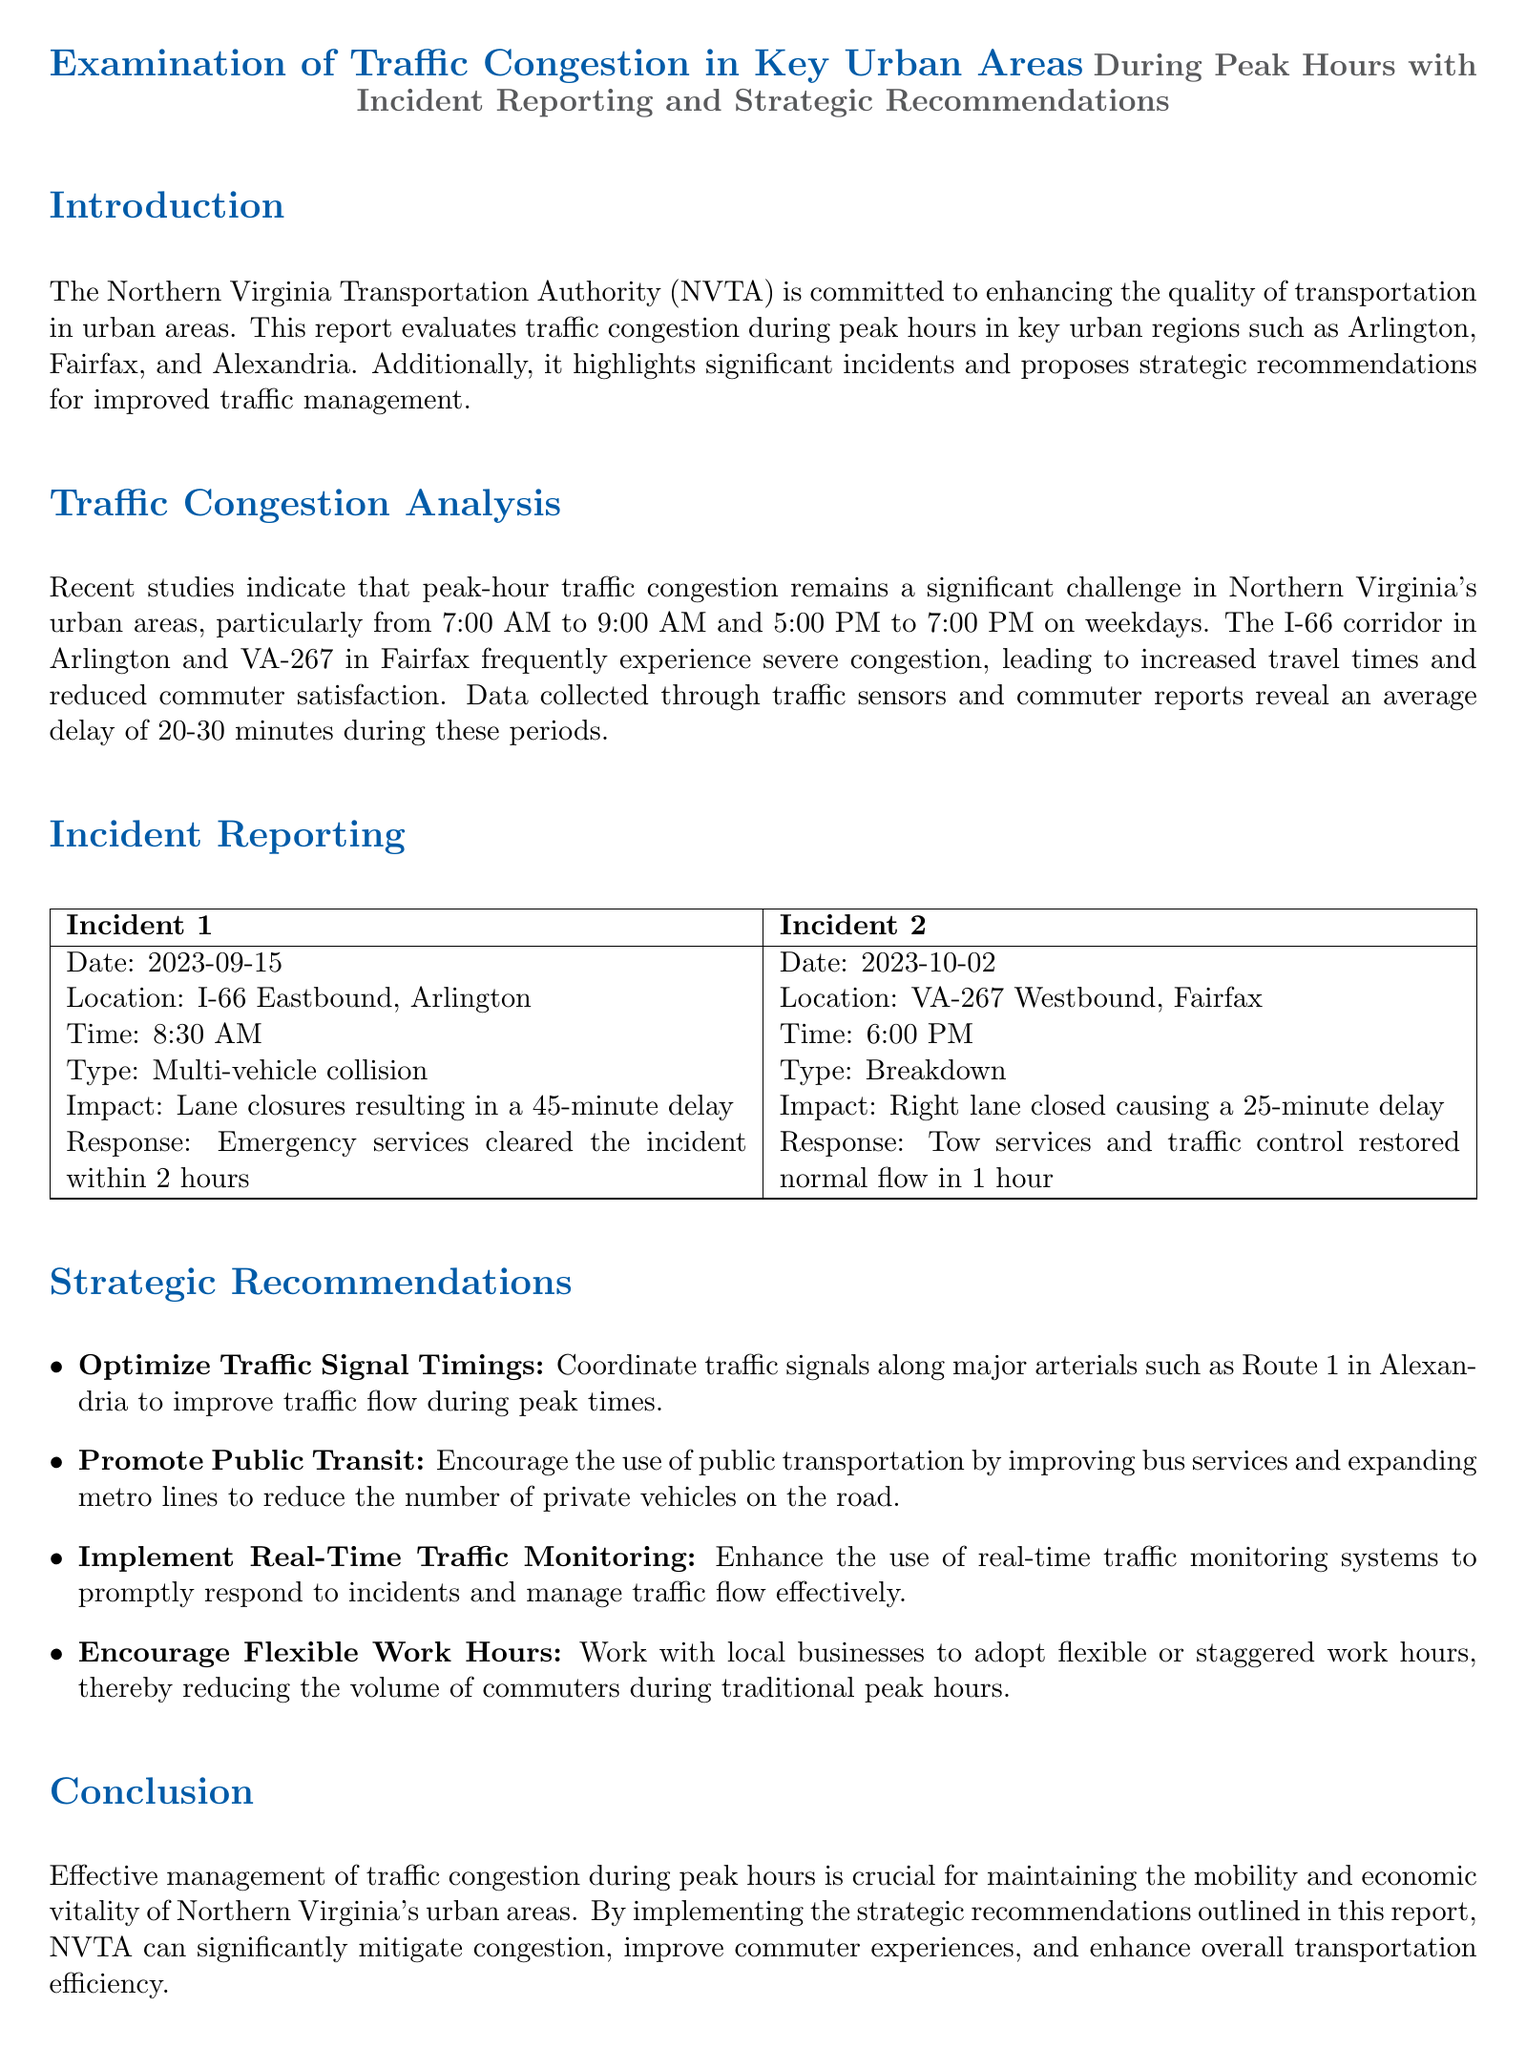What are the peak hours for traffic congestion? The peak hours for traffic congestion are specifically mentioned in the report as being from 7:00 AM to 9:00 AM and 5:00 PM to 7:00 PM on weekdays.
Answer: 7:00 AM to 9:00 AM and 5:00 PM to 7:00 PM Which corridor frequently experiences severe congestion in Arlington? The report identifies the I-66 corridor in Arlington as frequently experiencing severe congestion during peak hours.
Answer: I-66 What was the impact of Incident 1 on traffic? The incident report states that Incident 1 resulted in lane closures causing a 45-minute delay for commuters.
Answer: 45-minute delay How long did it take to clear Incident 2? According to the incident reporting section, it took 1 hour for tow services and traffic control to restore normal flow after Incident 2.
Answer: 1 hour What is one recommendation made for improving public transit? The report suggests encouraging the use of public transportation by improving bus services and expanding metro lines.
Answer: Improve bus services and expand metro lines What type of incident was reported on September 15, 2023? In the report, the incident on September 15, 2023, was classified as a multi-vehicle collision.
Answer: Multi-vehicle collision What is the average delay reported during peak hours? The document indicates that the average delay during peak hours is between 20 to 30 minutes based on traffic conditions.
Answer: 20-30 minutes Which location experienced a breakdown according to the incident report? The report specifies that the breakdown occurred at VA-267 Westbound in Fairfax.
Answer: VA-267 Westbound What is one strategic recommendation for traffic management made in the document? One of the strategic recommendations is to optimize traffic signal timings along major arterials to improve traffic flow during peak times.
Answer: Optimize Traffic Signal Timings 